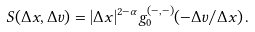Convert formula to latex. <formula><loc_0><loc_0><loc_500><loc_500>S ( \Delta x , \Delta v ) = | \Delta x | ^ { 2 - \alpha } g _ { 0 } ^ { ( - , - ) } ( - \Delta v / \Delta x ) \, .</formula> 